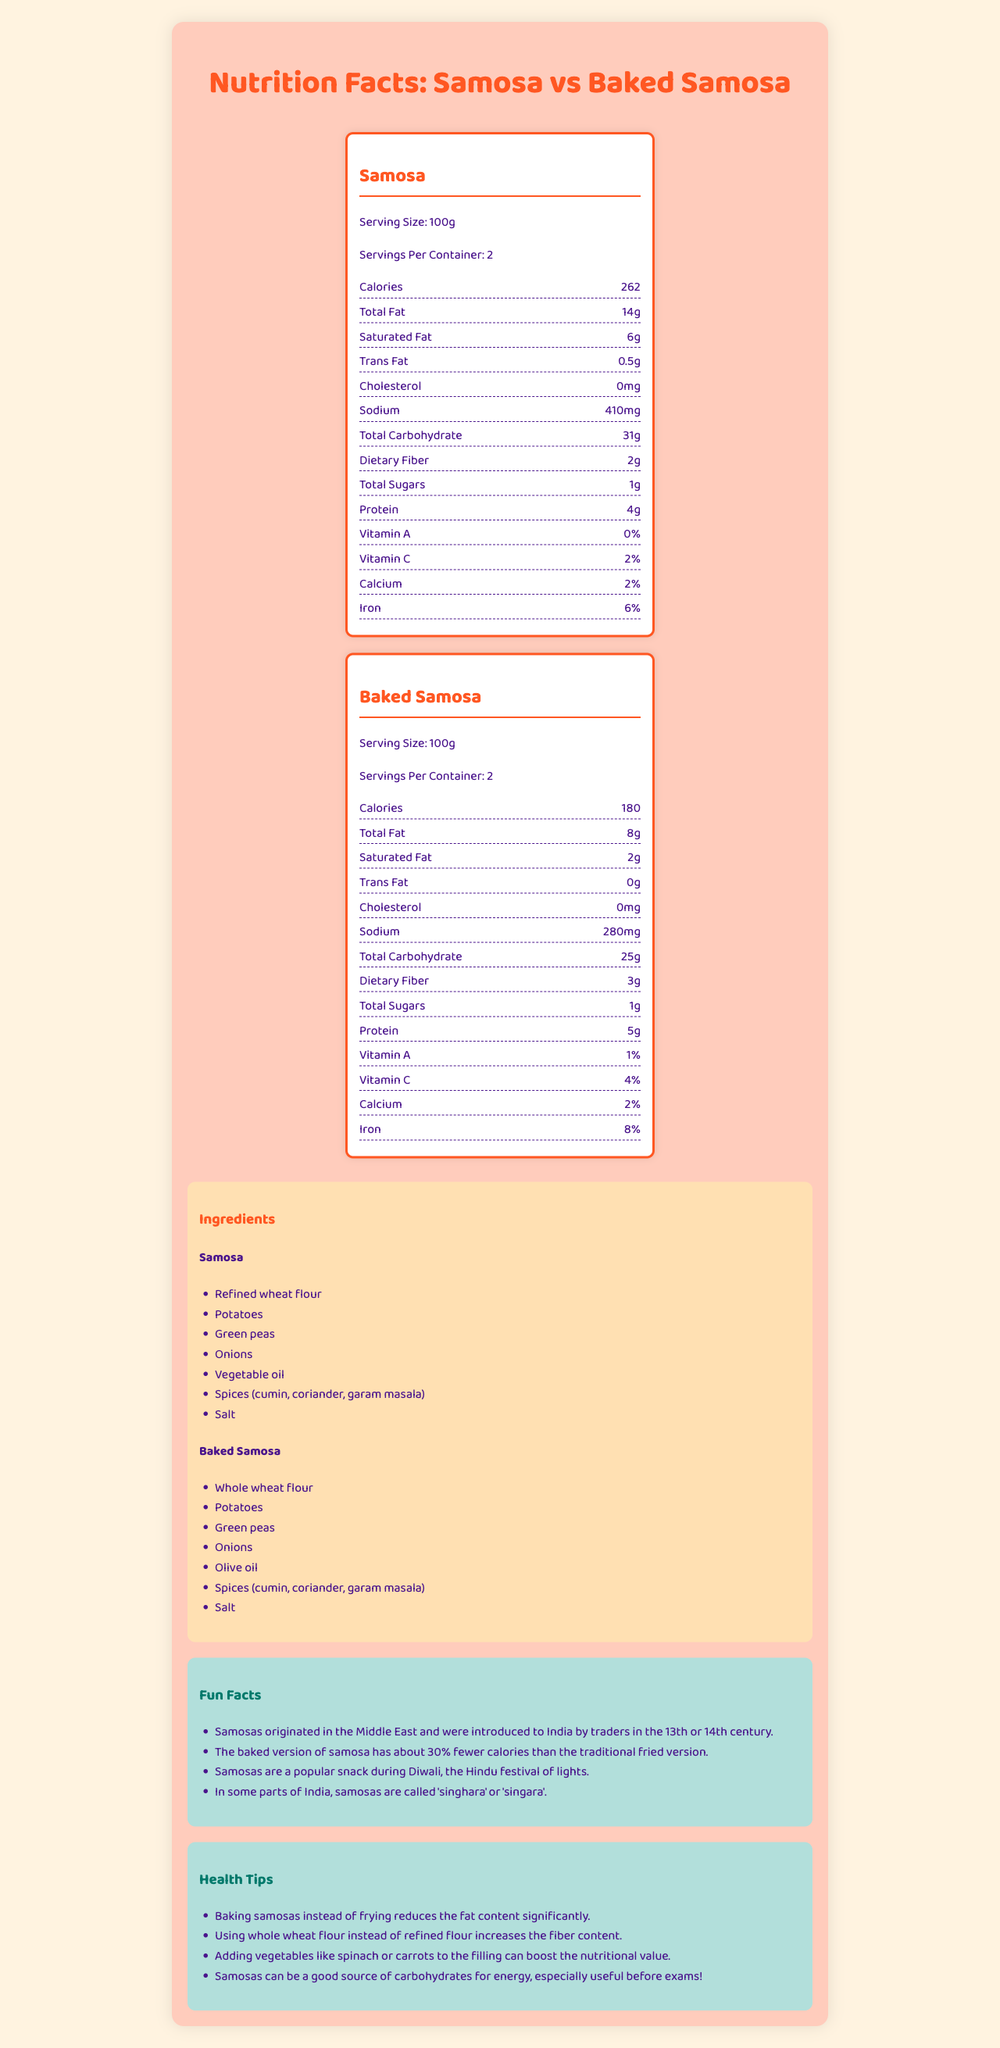what is the serving size for both the samosas? The document states that the serving size for both the street food samosa and the homemade baked samosa is 100g.
Answer: 100g How many calories are in a serving of street food samosa? The document provides a nutritional label that lists 262 calories per serving for the street food samosa.
Answer: 262 Which version has more dietary fiber? The homemade baked samosa has 3g of dietary fiber compared to 2g in the traditional street food samosa.
Answer: Homemade Baked Samosa Name two ingredients that differ between the street food samosa and the homemade samosa. The document lists refined wheat flour and vegetable oil for the street food samosa and whole wheat flour and olive oil for the homemade version.
Answer: Refined wheat flour and vegetable oil vs. whole wheat flour and olive oil What is the percentage of Vitamin C in the homemade samosa? The document's nutritional label for the homemade samosa lists Vitamin C at 4%.
Answer: 4% Which version contains less total fat per serving? A. Street Food Samosa B. Homemade Baked Samosa The document shows that the homemade baked samosa has a total fat content of 8g compared to the street food samosa's 14g.
Answer: B. Homemade Baked Samosa Which version has no trans fat? A. Street Food Samosa B. Homemade Baked Samosa C. Both D. Neither The street food samosa contains 0.5g of trans fat, while the homemade baked samosa has 0g.
Answer: B. Homemade Baked Samosa True or False: Both versions of the samosa have the same amount of total sugars. Both versions have 1g of total sugars according to their respective nutritional labels.
Answer: True Summarize the main differences in the nutritional values and ingredients of street food samosa versus homemade baked samosa. The document compares the nutritional values and ingredients between the street food samosa and the homemade baked samosa, highlighting the differences in caloric, fat, fiber, protein content, and types of ingredients used.
Answer: The street food samosa is higher in calories, total fat, saturated fat, and sodium but lower in dietary fiber and protein compared to the homemade baked samosa. The homemade version uses whole wheat flour and olive oil instead of refined wheat flour and vegetable oil. Can you determine the exact amount of grams of Vitamin A in either version of the samosas from the document? The document only provides the percentage of Vitamin A, not the exact amount in grams.
Answer: Cannot be determined What interesting fact is shared about samosa during Diwali in the document? One of the fun facts in the document states that samosas are a popular snack during Diwali.
Answer: Samosas are a popular snack during Diwali, the Hindu festival of lights. 